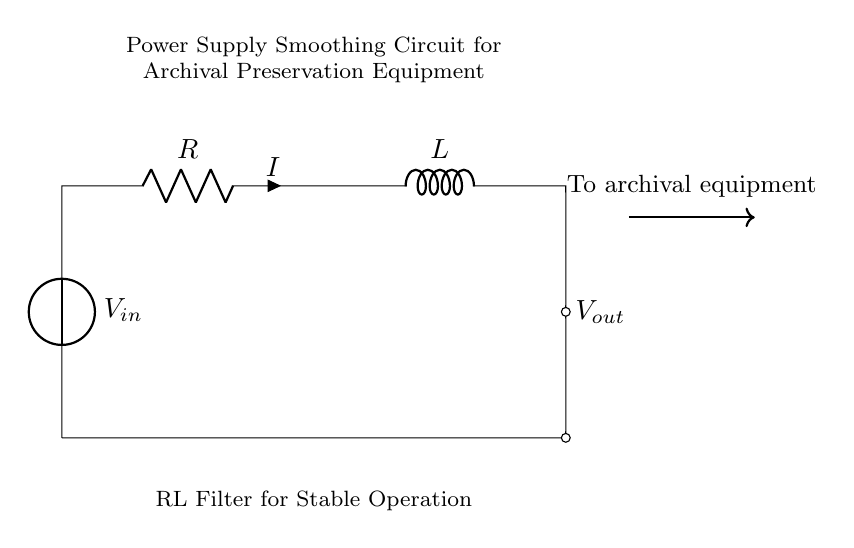What components are present in the circuit? The circuit consists of a voltage source, a resistor, and an inductor, all connected in series.
Answer: voltage source, resistor, inductor What does the symbol Vout represent? Vout represents the output voltage taken from the circuit, which is delivered to the archival equipment.
Answer: output voltage What is the role of the resistor in this circuit? The resistor limits the current flowing through the circuit, contributing to the smoothing effect of the voltage.
Answer: limits current Which component provides inductance in this circuit? The inductor is the component that provides inductance, which helps to smooth out voltage fluctuations.
Answer: inductor How do the resistor and inductor interact in this circuit? The resistor and inductor work together as an RL filter, where the resistor dissipates energy as heat, and the inductor stores energy in a magnetic field, helping to maintain stable current flow.
Answer: as an RL filter What happens to the output voltage when the input voltage changes? When the input voltage changes, the output voltage will stabilize due to the smoothing effect of the RL components, reducing any voltage ripple.
Answer: stabilizes What is the primary purpose of this circuit for archival preservation equipment? The primary purpose is to provide a stable, smooth voltage supply to ensure proper operation of the archival preservation equipment.
Answer: stable voltage supply 